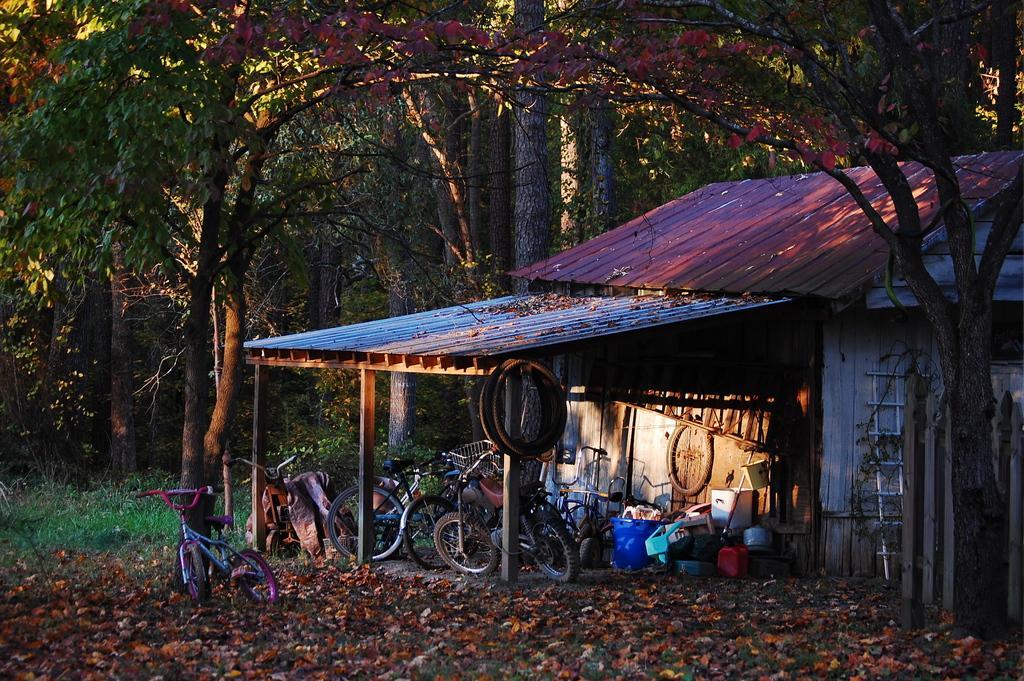Can you describe this image briefly? In this picture I can see a house. I can see bicycles, tyres and some other objects, and in the background there are plants and trees. 